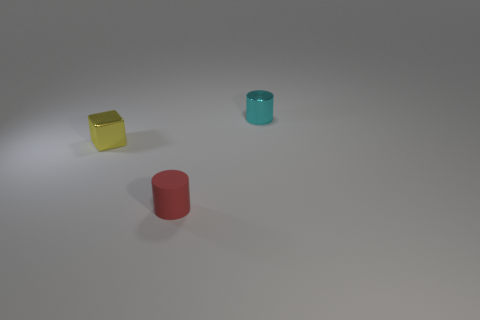Can you describe the lighting and mood the image evokes? The lighting in the image is subdued and diffused, creating a calm and minimalist atmosphere. There are no harsh shadows, and the soft glow on the surfaces of the objects conveys a serene, uncluttered mood, possibly suggesting a controlled, indoor environment. 